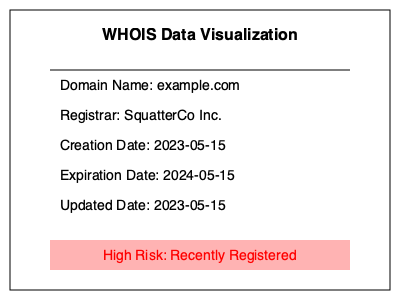Based on the WHOIS data visualization shown above, which characteristic of the domain registration indicates a potential risk of domain squatting? To identify potential domain squatting risks from WHOIS data, we need to analyze several factors:

1. Domain Name: The domain name "example.com" doesn't provide specific risk indicators in this case.

2. Registrar: "SquatterCo Inc." could be a red flag, but without additional context, it's not conclusive evidence.

3. Creation Date: The domain was created on 2023-05-15, which is very recent.

4. Expiration Date: Set for 2024-05-15, indicating a one-year registration period. Short registration periods can sometimes be associated with squatting, but it's not definitive.

5. Updated Date: Matches the creation date, which is normal for a new registration.

6. Risk Indicator: The visualization highlights "High Risk: Recently Registered" in red.

The most significant risk factor in this visualization is the recent creation date. Domain squatters often register domains shortly after they become available or expire, hoping to capitalize on their potential value or similarity to established brands.

The recent registration, combined with the explicit risk indicator, strongly suggests that the recency of the domain registration is the key characteristic indicating a potential risk of domain squatting.
Answer: Recent creation date 